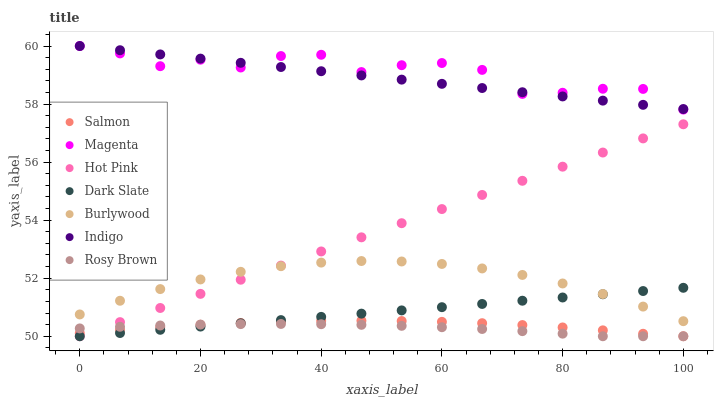Does Rosy Brown have the minimum area under the curve?
Answer yes or no. Yes. Does Magenta have the maximum area under the curve?
Answer yes or no. Yes. Does Indigo have the minimum area under the curve?
Answer yes or no. No. Does Indigo have the maximum area under the curve?
Answer yes or no. No. Is Indigo the smoothest?
Answer yes or no. Yes. Is Magenta the roughest?
Answer yes or no. Yes. Is Burlywood the smoothest?
Answer yes or no. No. Is Burlywood the roughest?
Answer yes or no. No. Does Rosy Brown have the lowest value?
Answer yes or no. Yes. Does Burlywood have the lowest value?
Answer yes or no. No. Does Magenta have the highest value?
Answer yes or no. Yes. Does Burlywood have the highest value?
Answer yes or no. No. Is Rosy Brown less than Indigo?
Answer yes or no. Yes. Is Magenta greater than Dark Slate?
Answer yes or no. Yes. Does Salmon intersect Rosy Brown?
Answer yes or no. Yes. Is Salmon less than Rosy Brown?
Answer yes or no. No. Is Salmon greater than Rosy Brown?
Answer yes or no. No. Does Rosy Brown intersect Indigo?
Answer yes or no. No. 